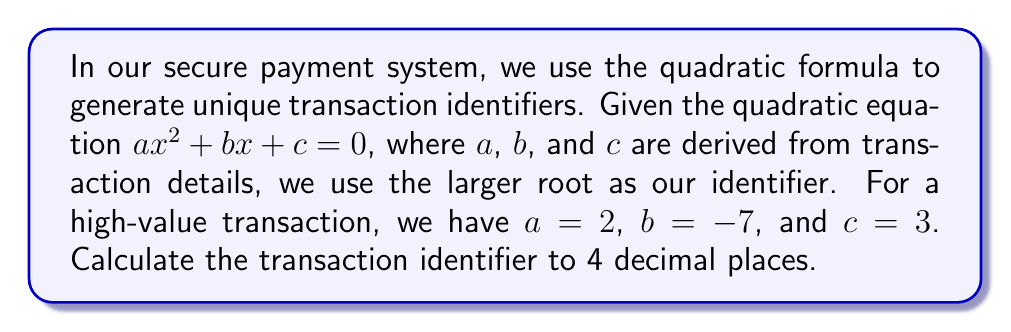What is the answer to this math problem? To solve this problem, we'll use the quadratic formula:

$$x = \frac{-b \pm \sqrt{b^2 - 4ac}}{2a}$$

Given:
$a = 2$
$b = -7$
$c = 3$

Let's substitute these values into the formula:

$$x = \frac{-(-7) \pm \sqrt{(-7)^2 - 4(2)(3)}}{2(2)}$$

Simplify:
$$x = \frac{7 \pm \sqrt{49 - 24}}{4}$$

$$x = \frac{7 \pm \sqrt{25}}{4}$$

$$x = \frac{7 \pm 5}{4}$$

This gives us two roots:

$$x_1 = \frac{7 + 5}{4} = \frac{12}{4} = 3$$

$$x_2 = \frac{7 - 5}{4} = \frac{2}{4} = 0.5$$

Since we need the larger root as our identifier, we'll use $x_1 = 3$.

The question asks for the result to 4 decimal places, so our final answer is 3.0000.
Answer: 3.0000 